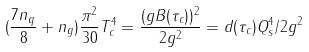Convert formula to latex. <formula><loc_0><loc_0><loc_500><loc_500>( \frac { 7 n _ { q } } { 8 } + n _ { g } ) \frac { \pi ^ { 2 } } { 3 0 } T _ { c } ^ { 4 } = \frac { ( g B ( \tau _ { c } ) ) ^ { 2 } } { 2 g ^ { 2 } } = d ( \tau _ { c } ) Q _ { s } ^ { 4 } / 2 g ^ { 2 }</formula> 